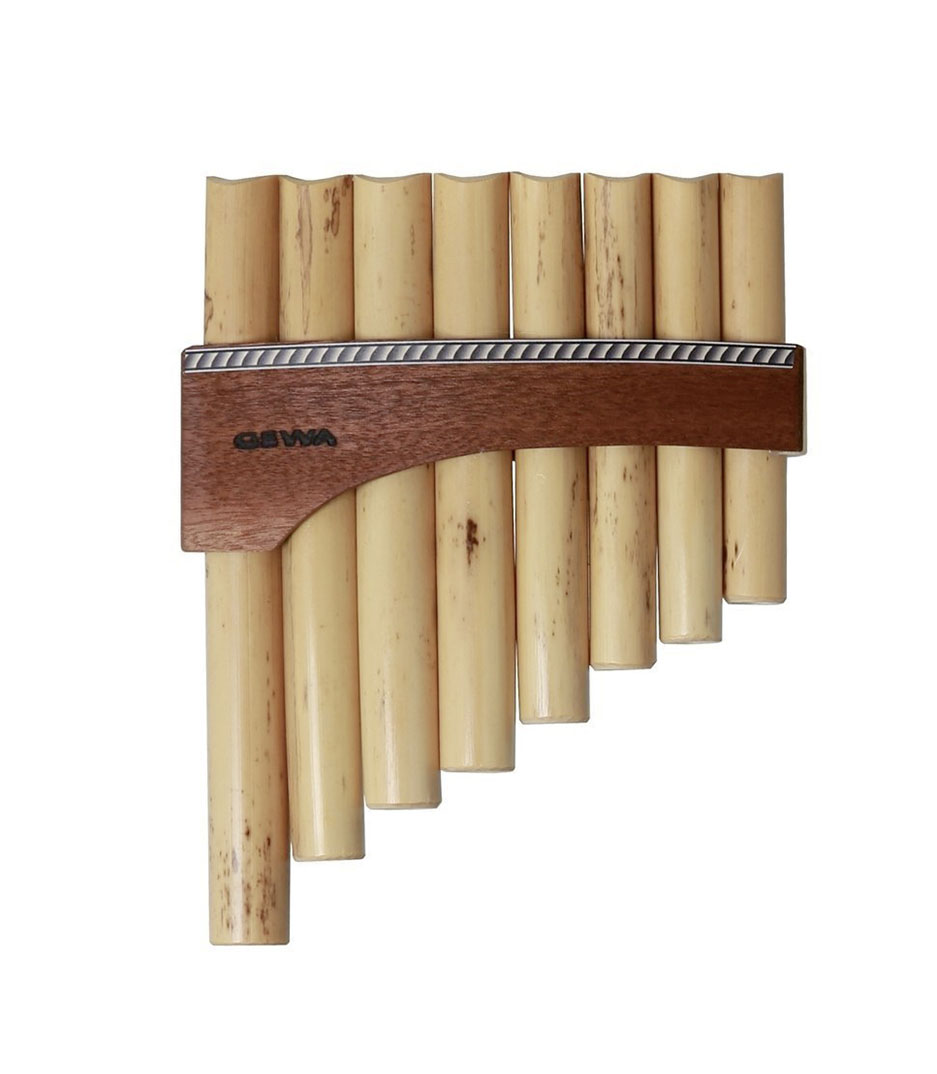Given the variation in length of the pipes and their arrangement, what might be the range of notes this pan flute can play, and how does the length of each pipe correlate to the pitch produced? The range of notes that this pan flute can produce depends on the lengths of its individual pipes. In general, longer pipes on the instrument produce lower pitches, while shorter pipes yield higher pitches. Given the visibly marked variation in pipe lengths in this image, this pan flute can likely cover a note range that spans at least one octave, potentially extending further. Each pipe functions as a closed tube resonator, meaning the longer the pipe, the lower the pitch it produces, which is a fundamental principle in the physics of sound. Understanding this can be especially intriguing when considering traditional uses of pan flutes in world music where they create rich, melodic landscapes. 